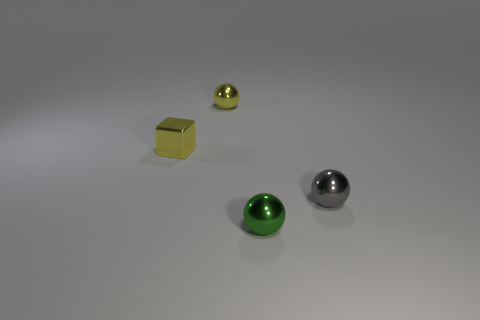Add 4 green metal objects. How many objects exist? 8 Subtract all balls. How many objects are left? 1 Add 2 small green metal things. How many small green metal things are left? 3 Add 1 tiny gray metallic spheres. How many tiny gray metallic spheres exist? 2 Subtract 0 brown cubes. How many objects are left? 4 Subtract all tiny green shiny spheres. Subtract all tiny gray metallic objects. How many objects are left? 2 